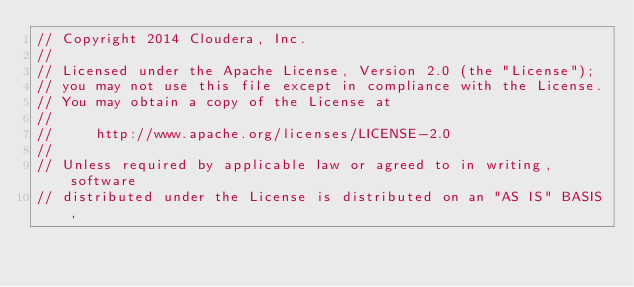Convert code to text. <code><loc_0><loc_0><loc_500><loc_500><_C++_>// Copyright 2014 Cloudera, Inc.
//
// Licensed under the Apache License, Version 2.0 (the "License");
// you may not use this file except in compliance with the License.
// You may obtain a copy of the License at
//
//     http://www.apache.org/licenses/LICENSE-2.0
//
// Unless required by applicable law or agreed to in writing, software
// distributed under the License is distributed on an "AS IS" BASIS,</code> 